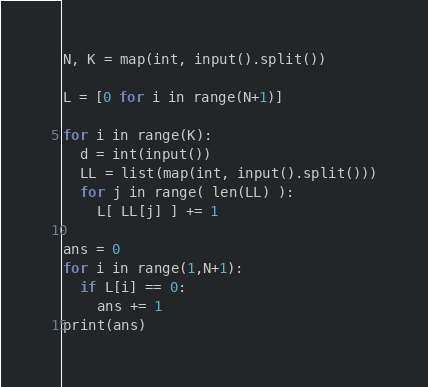<code> <loc_0><loc_0><loc_500><loc_500><_Python_>N, K = map(int, input().split())

L = [0 for i in range(N+1)]

for i in range(K):
  d = int(input())
  LL = list(map(int, input().split()))
  for j in range( len(LL) ):
    L[ LL[j] ] += 1

ans = 0
for i in range(1,N+1):
  if L[i] == 0:
    ans += 1
print(ans)</code> 